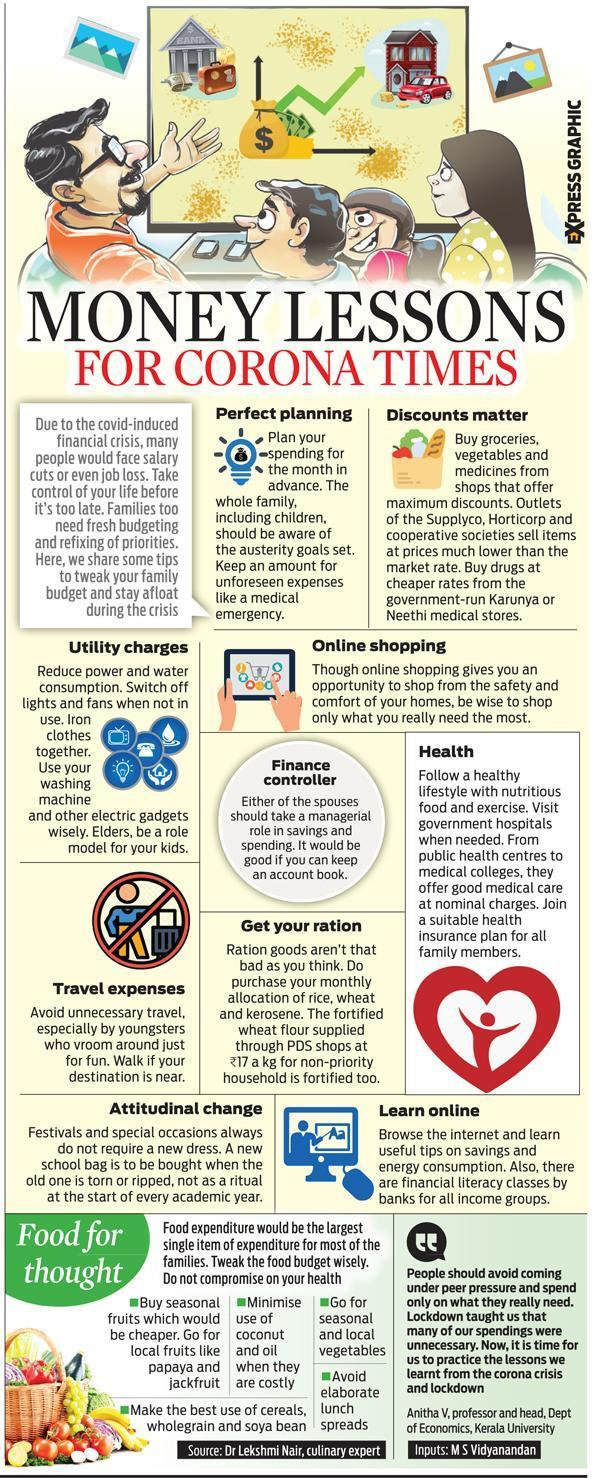How many local fruits are mentioned in this infographic?
Answer the question with a short phrase. 2 